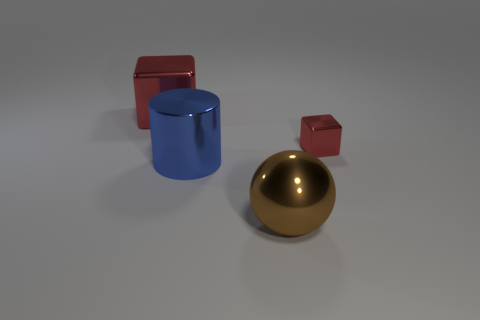Add 4 red matte balls. How many objects exist? 8 Subtract all spheres. How many objects are left? 3 Subtract all tiny metal cubes. Subtract all blue metallic cylinders. How many objects are left? 2 Add 3 blue cylinders. How many blue cylinders are left? 4 Add 1 small metal things. How many small metal things exist? 2 Subtract 0 brown cylinders. How many objects are left? 4 